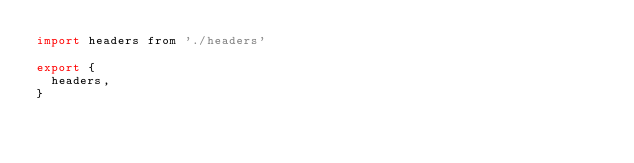<code> <loc_0><loc_0><loc_500><loc_500><_JavaScript_>import headers from './headers'

export {
  headers,
}
</code> 